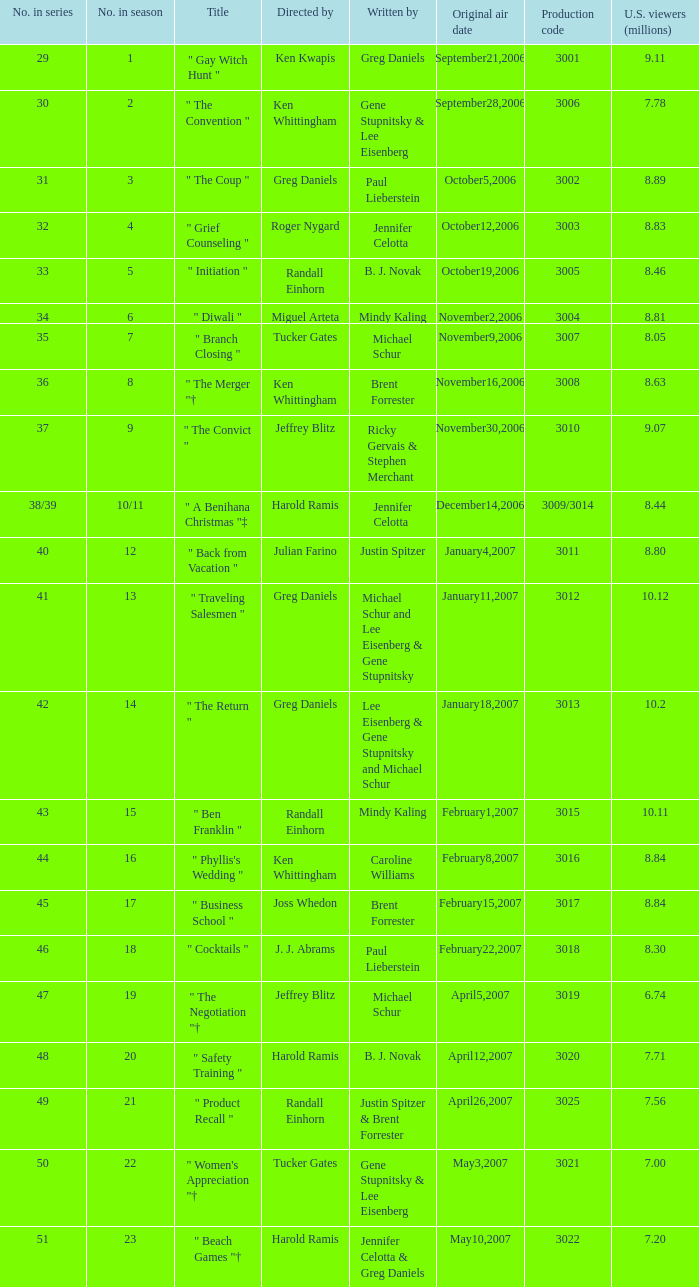Identify the quantity of original broadcast dates for episodes with a season placement of 10/1 1.0. 